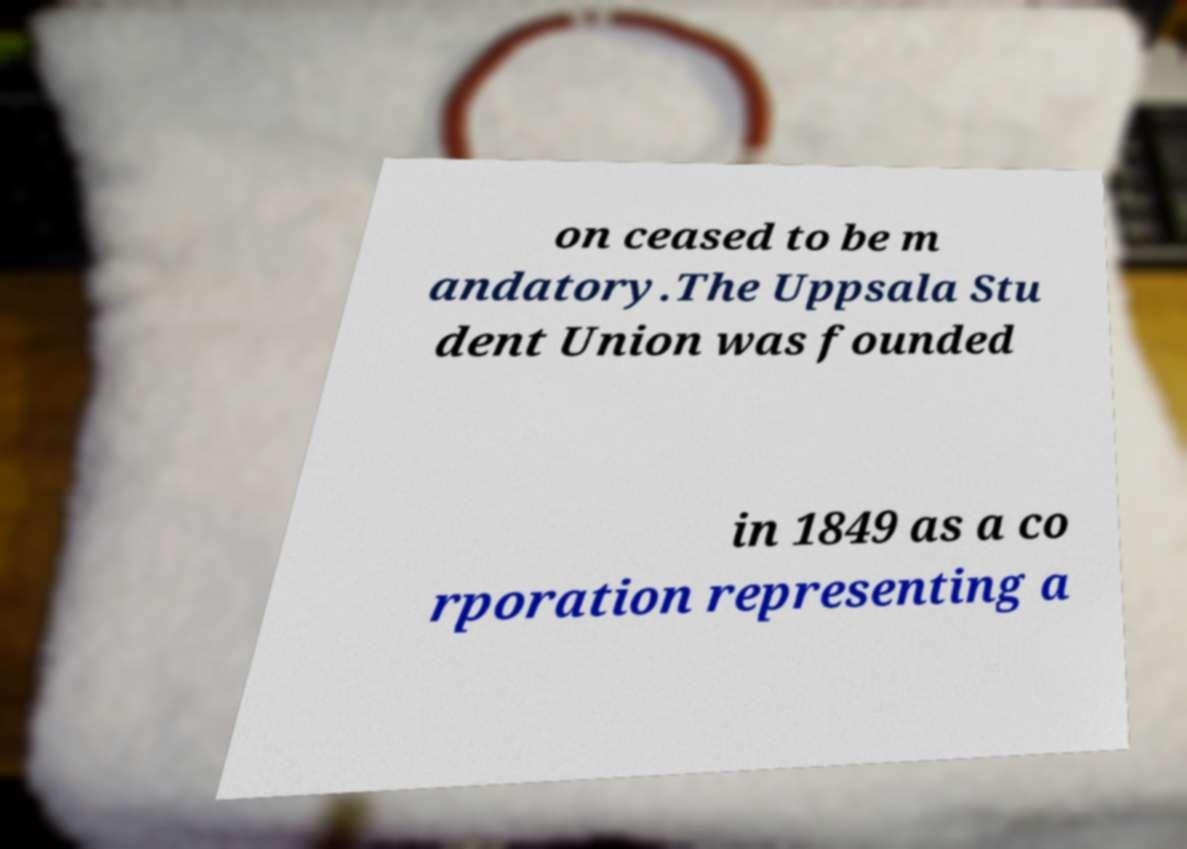Could you extract and type out the text from this image? on ceased to be m andatory.The Uppsala Stu dent Union was founded in 1849 as a co rporation representing a 